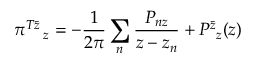<formula> <loc_0><loc_0><loc_500><loc_500>\pi _ { z } ^ { T \bar { z } } = - \frac { 1 } { 2 \pi } \sum _ { n } \frac { P _ { n z } } { z - z _ { n } } + P _ { z } ^ { \bar { z } } ( z )</formula> 